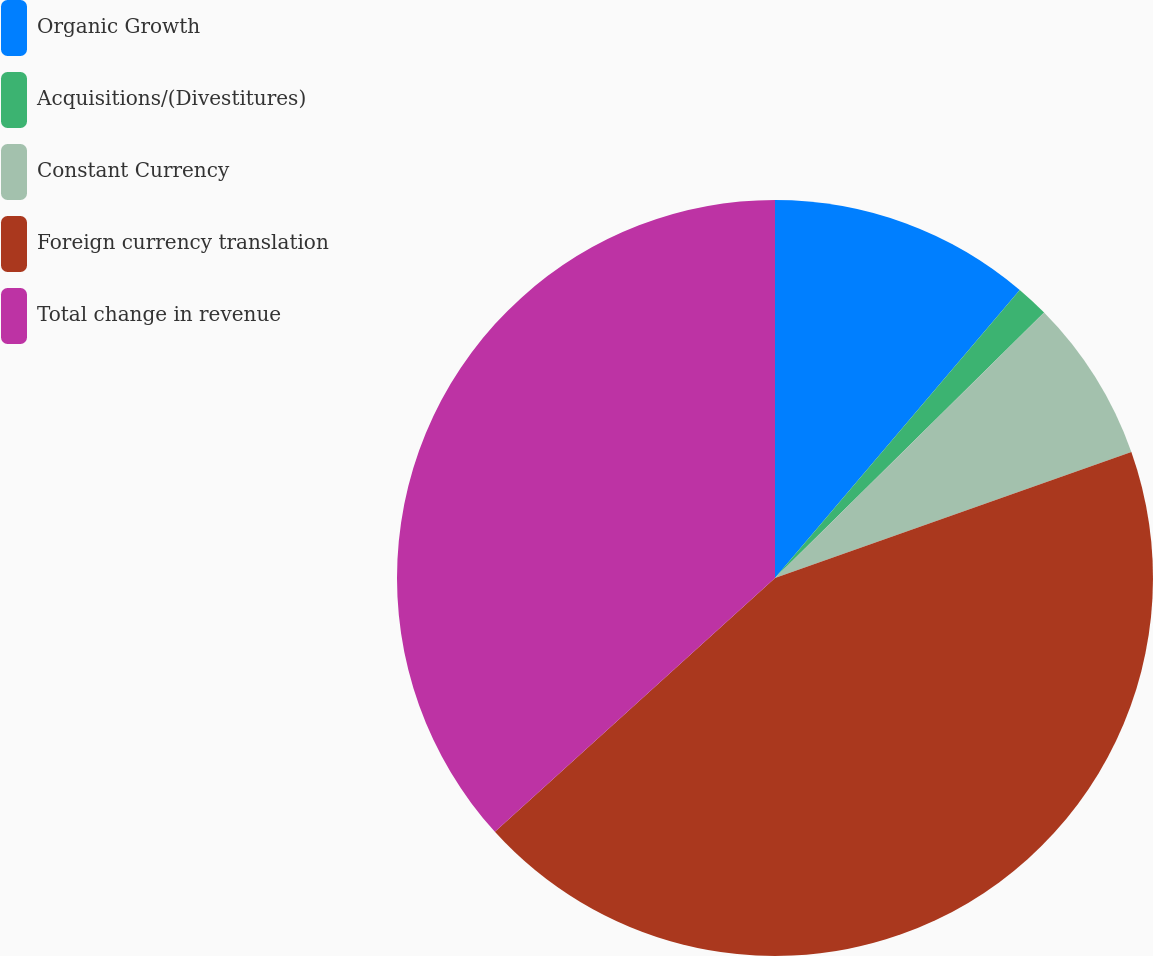Convert chart to OTSL. <chart><loc_0><loc_0><loc_500><loc_500><pie_chart><fcel>Organic Growth<fcel>Acquisitions/(Divestitures)<fcel>Constant Currency<fcel>Foreign currency translation<fcel>Total change in revenue<nl><fcel>11.21%<fcel>1.4%<fcel>6.98%<fcel>43.7%<fcel>36.72%<nl></chart> 